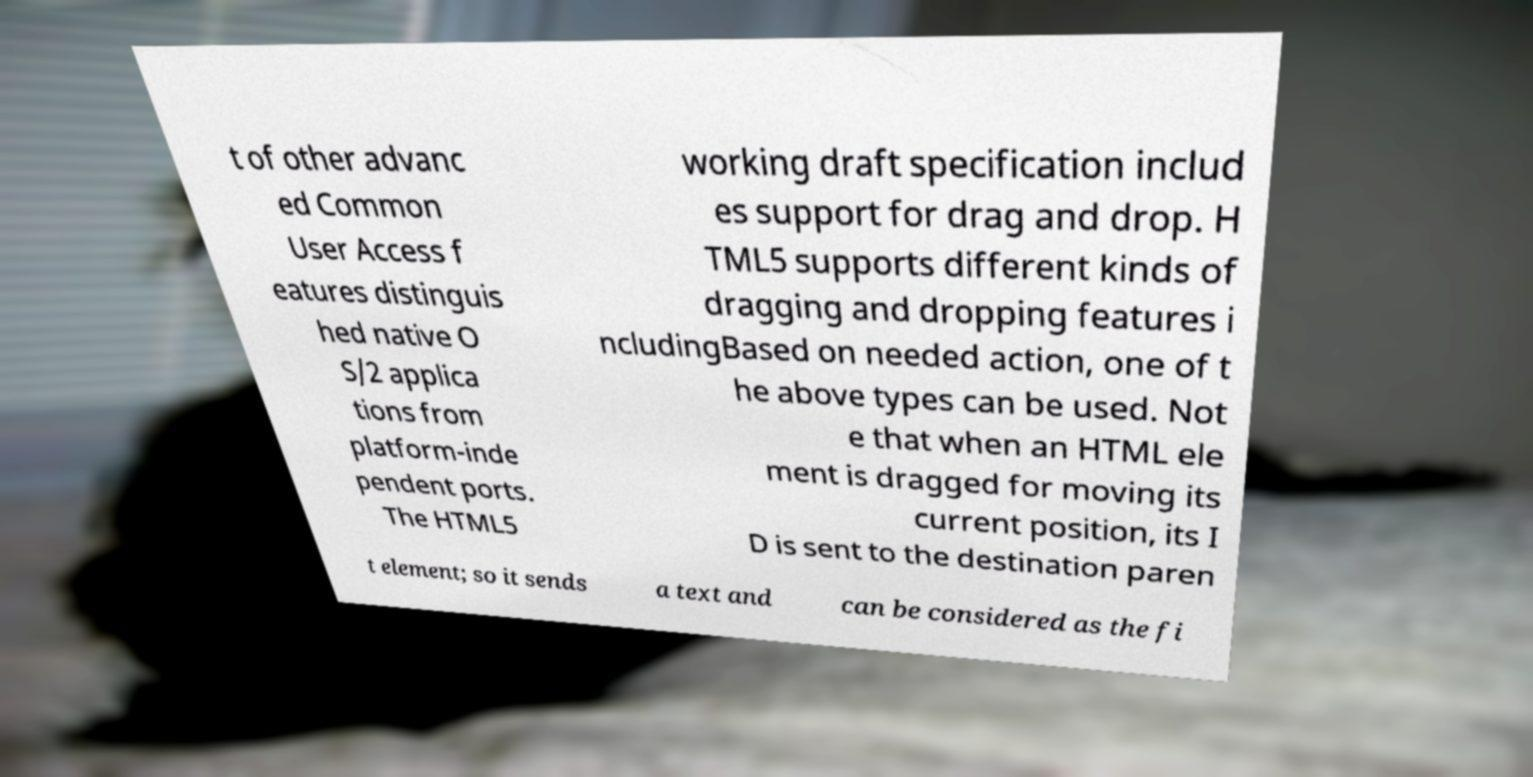There's text embedded in this image that I need extracted. Can you transcribe it verbatim? t of other advanc ed Common User Access f eatures distinguis hed native O S/2 applica tions from platform-inde pendent ports. The HTML5 working draft specification includ es support for drag and drop. H TML5 supports different kinds of dragging and dropping features i ncludingBased on needed action, one of t he above types can be used. Not e that when an HTML ele ment is dragged for moving its current position, its I D is sent to the destination paren t element; so it sends a text and can be considered as the fi 